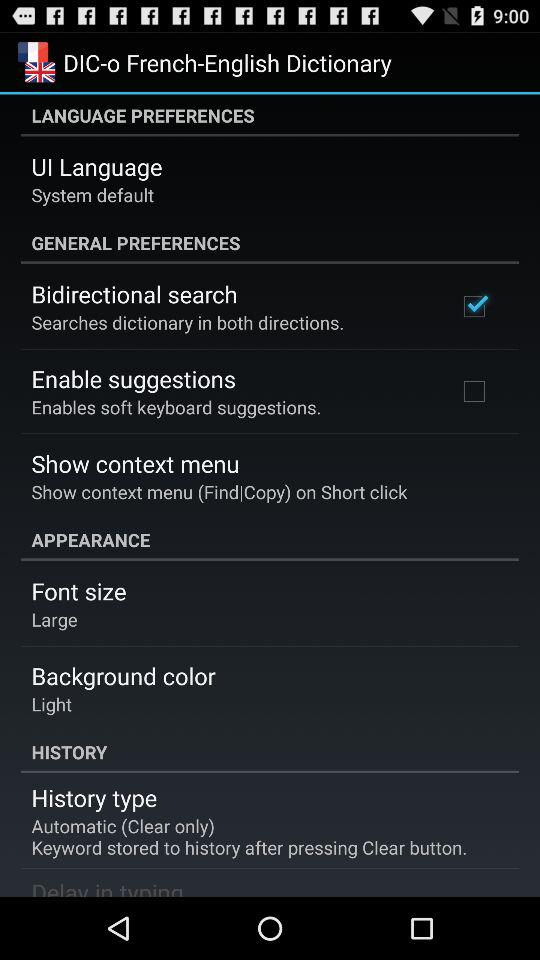What's the set "History type"? The set "History type" is automatic. 